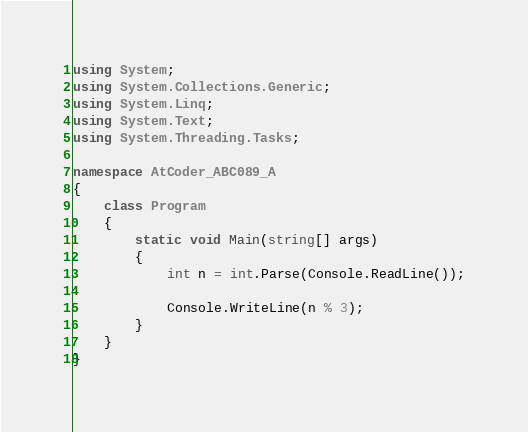<code> <loc_0><loc_0><loc_500><loc_500><_C#_>using System;
using System.Collections.Generic;
using System.Linq;
using System.Text;
using System.Threading.Tasks;

namespace AtCoder_ABC089_A
{
    class Program
    {
        static void Main(string[] args)
        {
            int n = int.Parse(Console.ReadLine());

            Console.WriteLine(n % 3);
        }
    }
}
</code> 